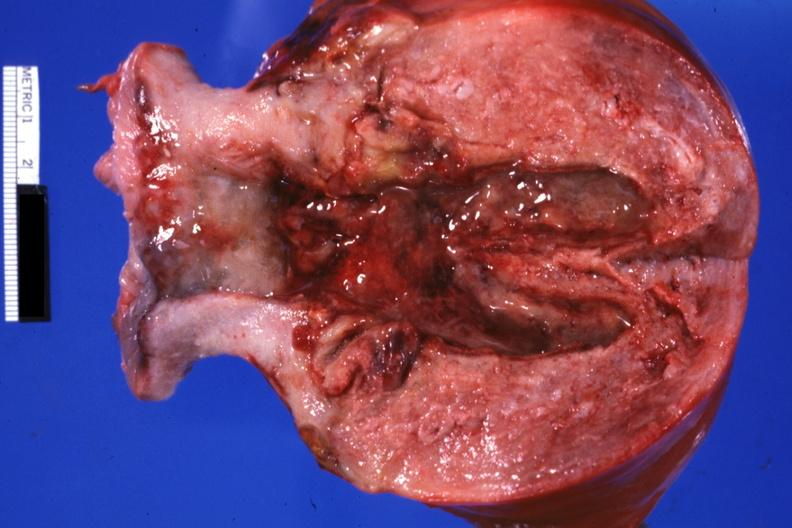s endometritis postpartum present?
Answer the question using a single word or phrase. Yes 